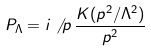<formula> <loc_0><loc_0><loc_500><loc_500>P _ { \Lambda } = i \not \, { p } \, \frac { K ( p ^ { 2 } / \Lambda ^ { 2 } ) } { p ^ { 2 } }</formula> 